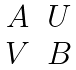Convert formula to latex. <formula><loc_0><loc_0><loc_500><loc_500>\begin{matrix} A & U \\ V & B \end{matrix}</formula> 